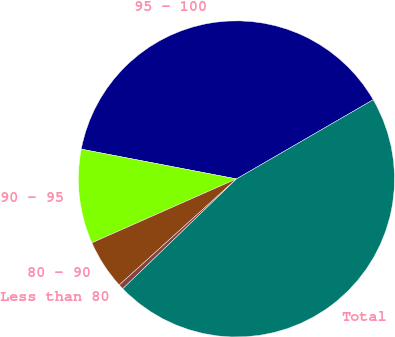Convert chart. <chart><loc_0><loc_0><loc_500><loc_500><pie_chart><fcel>95 - 100<fcel>90 - 95<fcel>80 - 90<fcel>Less than 80<fcel>Total<nl><fcel>38.63%<fcel>9.64%<fcel>5.08%<fcel>0.52%<fcel>46.13%<nl></chart> 